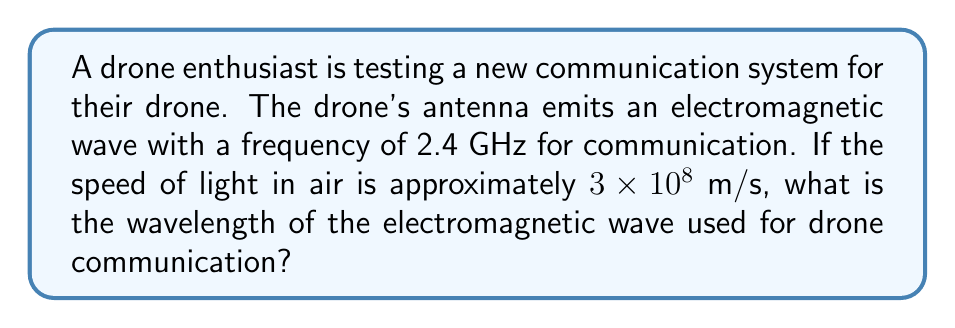What is the answer to this math problem? To solve this problem, we'll use the wave equation that relates the speed of light, frequency, and wavelength of an electromagnetic wave:

$$c = f \lambda$$

Where:
$c$ is the speed of light in air
$f$ is the frequency of the wave
$\lambda$ is the wavelength

We're given:
$c = 3 \times 10^8$ m/s
$f = 2.4$ GHz $= 2.4 \times 10^9$ Hz

Step 1: Rearrange the equation to solve for wavelength:
$$\lambda = \frac{c}{f}$$

Step 2: Substitute the known values:
$$\lambda = \frac{3 \times 10^8 \text{ m/s}}{2.4 \times 10^9 \text{ Hz}}$$

Step 3: Calculate the result:
$$\lambda = \frac{3}{2.4} \times \frac{10^8}{10^9} = 0.125 \text{ m}$$

Step 4: Convert to centimeters for a more practical unit in drone applications:
$$\lambda = 0.125 \text{ m} \times 100 \text{ cm/m} = 12.5 \text{ cm}$$
Answer: 12.5 cm 